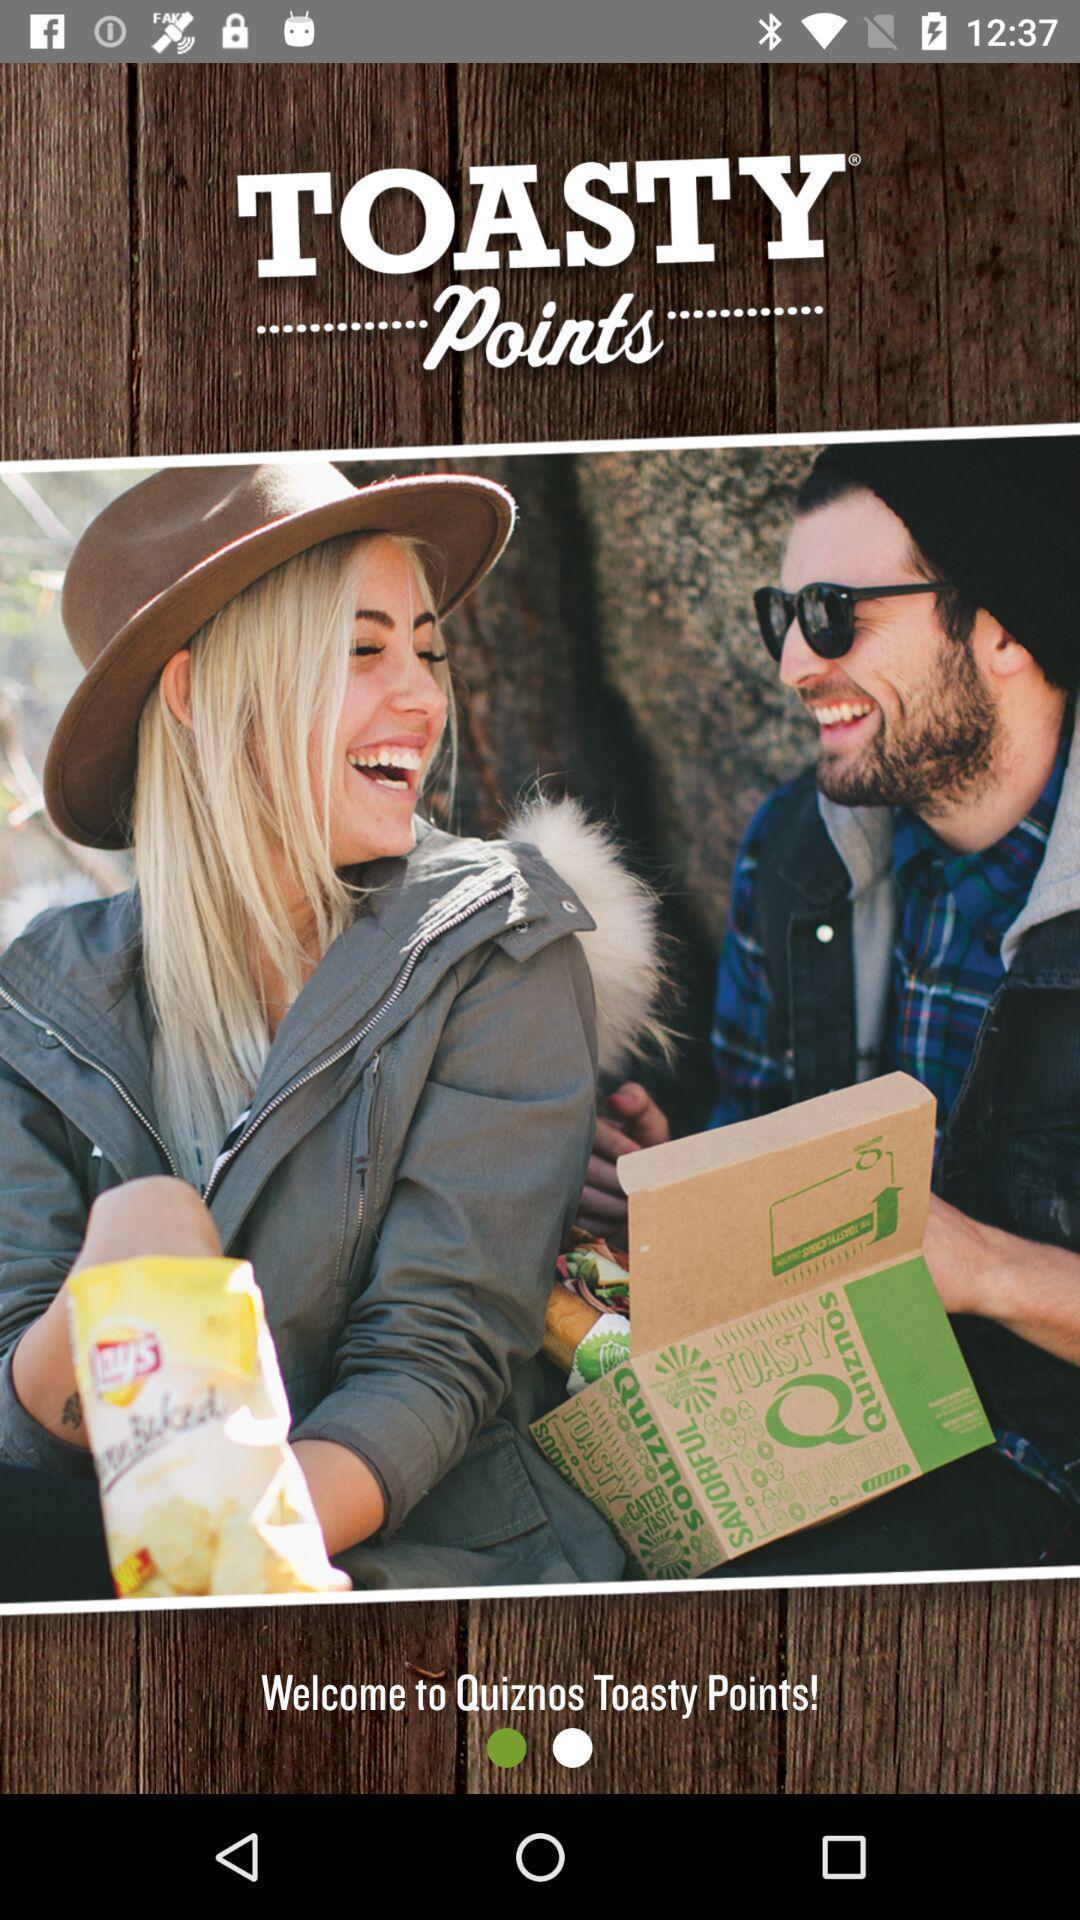Explain the elements present in this screenshot. Welcome page. 